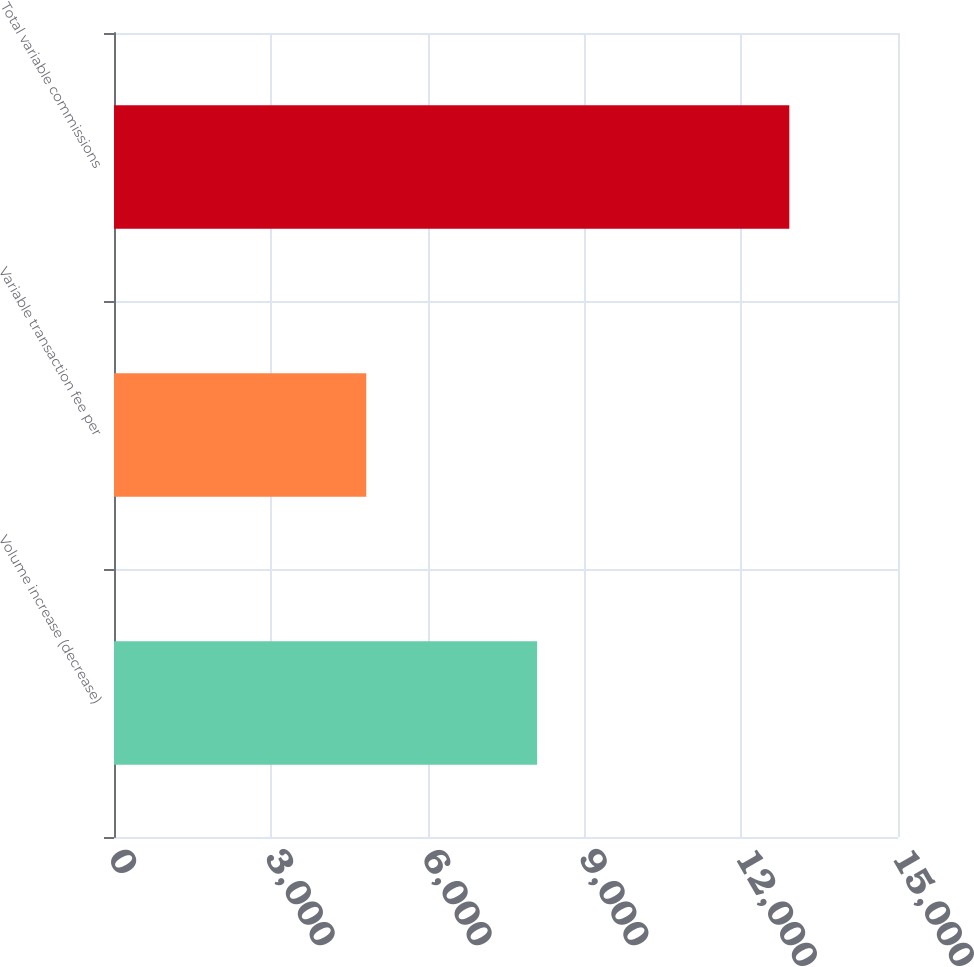Convert chart to OTSL. <chart><loc_0><loc_0><loc_500><loc_500><bar_chart><fcel>Volume increase (decrease)<fcel>Variable transaction fee per<fcel>Total variable commissions<nl><fcel>8095<fcel>4826<fcel>12921<nl></chart> 